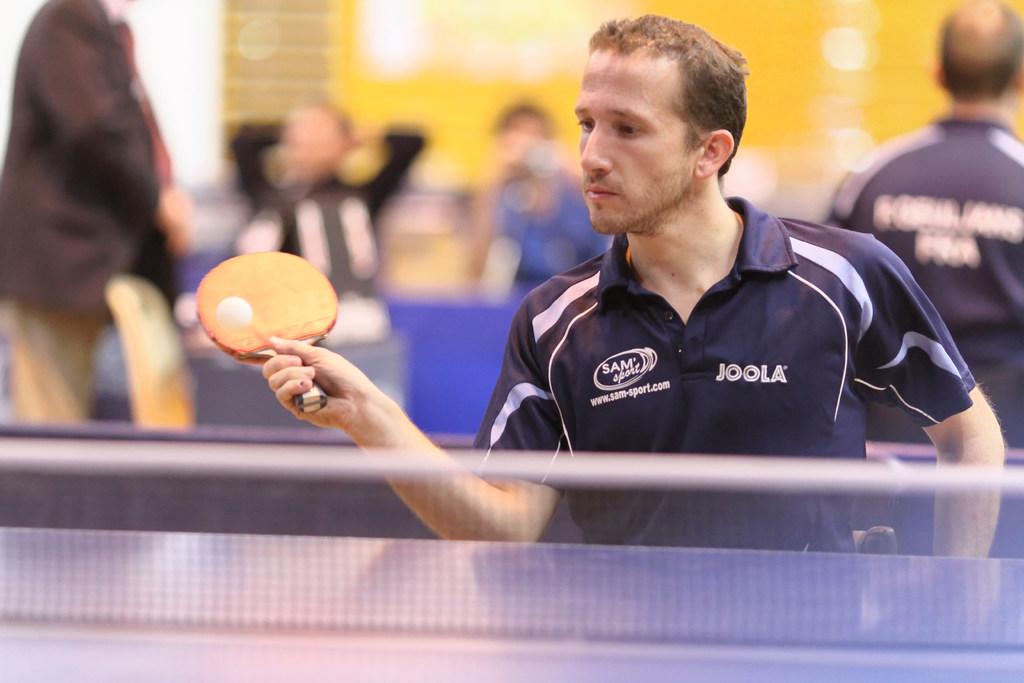What brand name is on the mans shirt to the right?
Your response must be concise. Joola. 